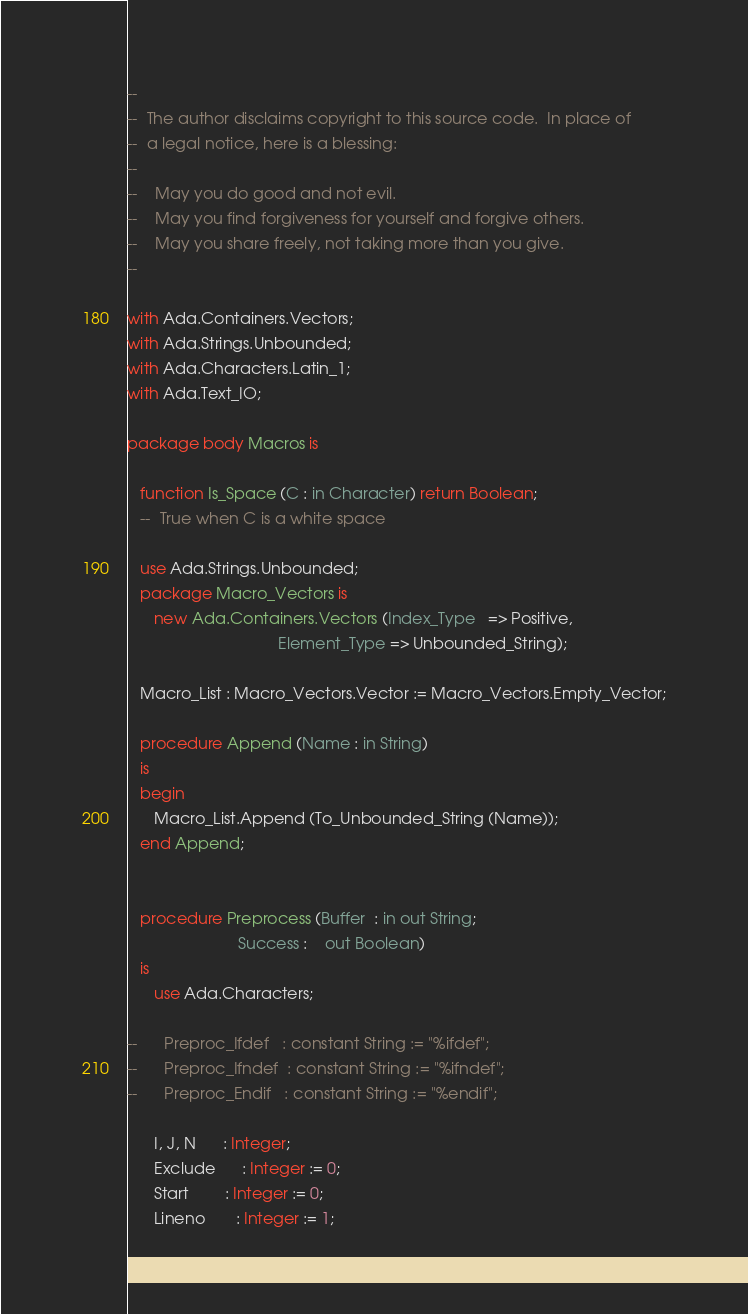Convert code to text. <code><loc_0><loc_0><loc_500><loc_500><_Ada_>--
--  The author disclaims copyright to this source code.  In place of
--  a legal notice, here is a blessing:
--
--    May you do good and not evil.
--    May you find forgiveness for yourself and forgive others.
--    May you share freely, not taking more than you give.
--

with Ada.Containers.Vectors;
with Ada.Strings.Unbounded;
with Ada.Characters.Latin_1;
with Ada.Text_IO;

package body Macros is

   function Is_Space (C : in Character) return Boolean;
   --  True when C is a white space

   use Ada.Strings.Unbounded;
   package Macro_Vectors is
      new Ada.Containers.Vectors (Index_Type   => Positive,
                                  Element_Type => Unbounded_String);

   Macro_List : Macro_Vectors.Vector := Macro_Vectors.Empty_Vector;

   procedure Append (Name : in String)
   is
   begin
      Macro_List.Append (To_Unbounded_String (Name));
   end Append;


   procedure Preprocess (Buffer  : in out String;
                         Success :    out Boolean)
   is
      use Ada.Characters;

--      Preproc_Ifdef   : constant String := "%ifdef";
--      Preproc_Ifndef  : constant String := "%ifndef";
--      Preproc_Endif   : constant String := "%endif";

      I, J, N      : Integer;
      Exclude      : Integer := 0;
      Start        : Integer := 0;
      Lineno       : Integer := 1;</code> 